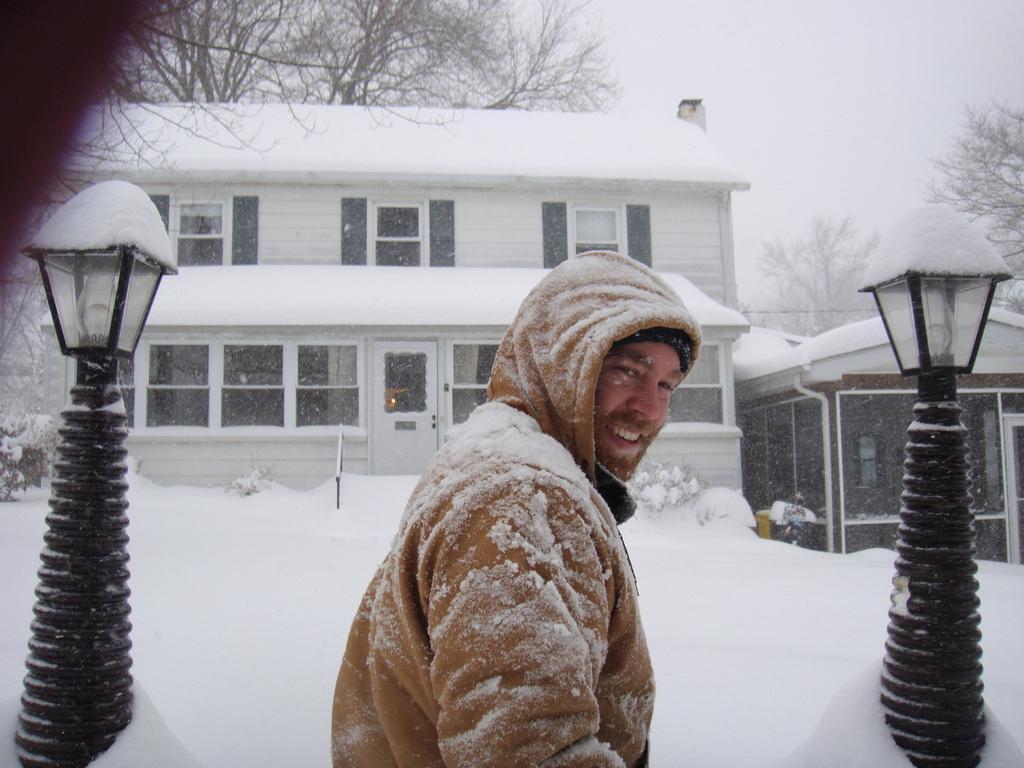How would you summarize this image in a sentence or two? In this picture we can see a man wore a jacket and smiling, poles, lights, buildings with windows, plants, trees, door, snow and some objects and in the background we can see the sky. 